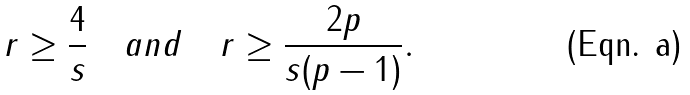<formula> <loc_0><loc_0><loc_500><loc_500>r \geq \frac { 4 } { s } \quad a n d \quad r \geq \frac { 2 p } { s ( p - 1 ) } .</formula> 